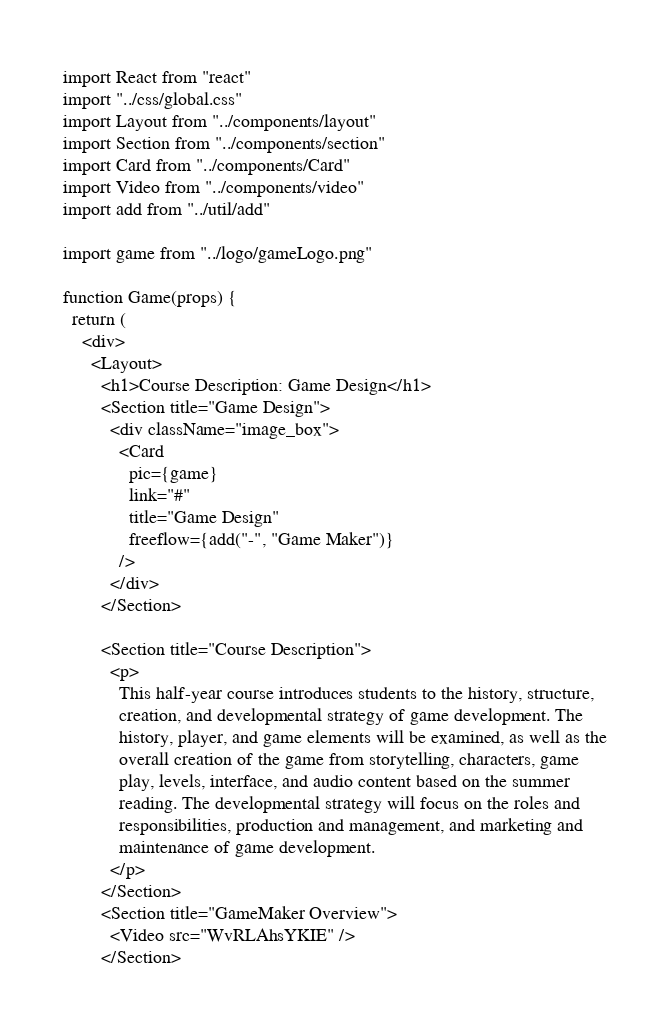Convert code to text. <code><loc_0><loc_0><loc_500><loc_500><_JavaScript_>import React from "react"
import "../css/global.css"
import Layout from "../components/layout"
import Section from "../components/section"
import Card from "../components/Card"
import Video from "../components/video"
import add from "../util/add"

import game from "../logo/gameLogo.png"

function Game(props) {
  return (
    <div>
      <Layout>
        <h1>Course Description: Game Design</h1>
        <Section title="Game Design">
          <div className="image_box">
            <Card
              pic={game}
              link="#"
              title="Game Design"
              freeflow={add("-", "Game Maker")}
            />
          </div>
        </Section>

        <Section title="Course Description">
          <p>
            This half-year course introduces students to the history, structure,
            creation, and developmental strategy of game development. The
            history, player, and game elements will be examined, as well as the
            overall creation of the game from storytelling, characters, game
            play, levels, interface, and audio content based on the summer
            reading. The developmental strategy will focus on the roles and
            responsibilities, production and management, and marketing and
            maintenance of game development.
          </p>
        </Section>
        <Section title="GameMaker Overview">
          <Video src="WvRLAhsYKIE" />
        </Section></code> 